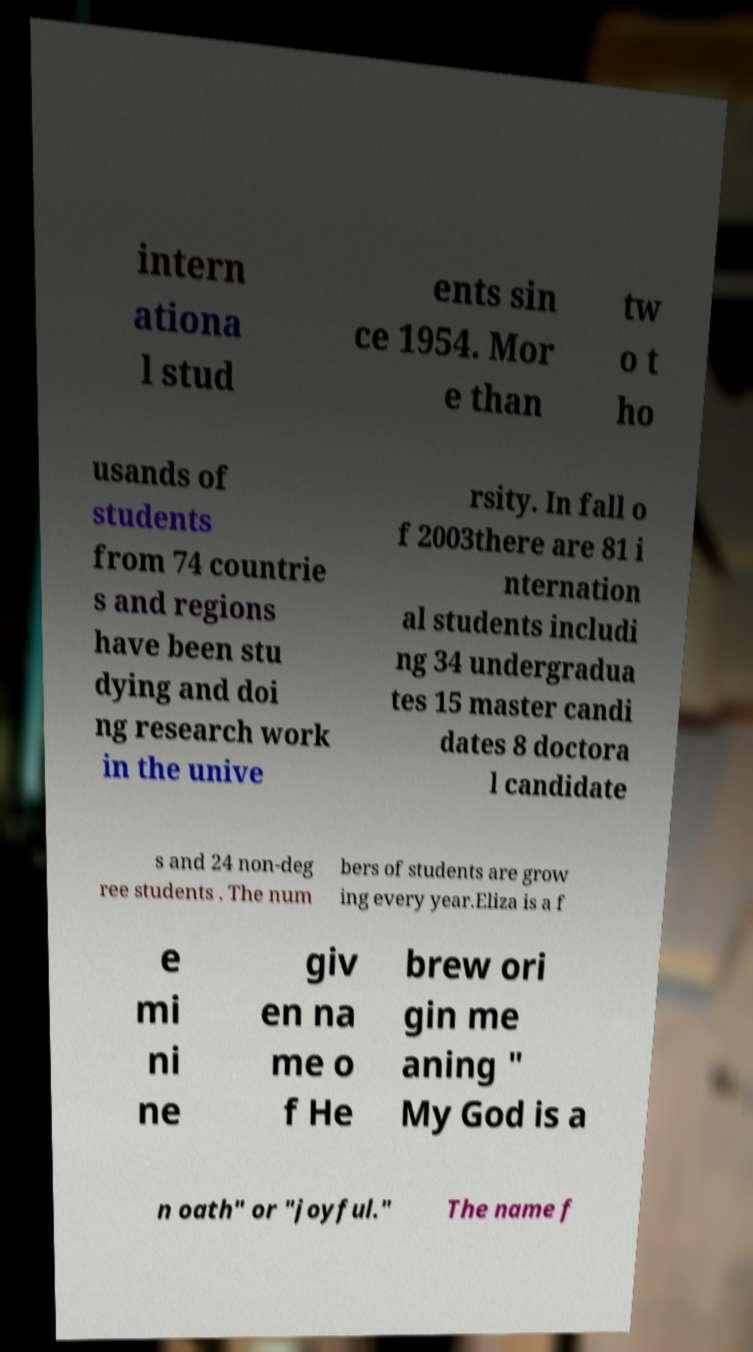Please read and relay the text visible in this image. What does it say? intern ationa l stud ents sin ce 1954. Mor e than tw o t ho usands of students from 74 countrie s and regions have been stu dying and doi ng research work in the unive rsity. In fall o f 2003there are 81 i nternation al students includi ng 34 undergradua tes 15 master candi dates 8 doctora l candidate s and 24 non-deg ree students . The num bers of students are grow ing every year.Eliza is a f e mi ni ne giv en na me o f He brew ori gin me aning " My God is a n oath" or "joyful." The name f 